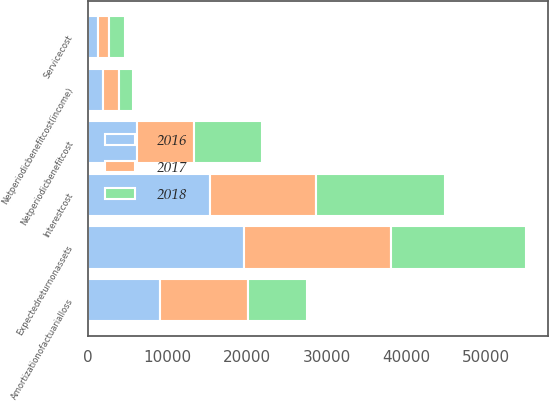Convert chart to OTSL. <chart><loc_0><loc_0><loc_500><loc_500><stacked_bar_chart><ecel><fcel>Servicecost<fcel>Interestcost<fcel>Expectedreturnonassets<fcel>Amortizationofactuarialloss<fcel>Netperiodicbenefitcost<fcel>Netperiodicbenefitcost(income)<nl><fcel>2017<fcel>1300<fcel>13358<fcel>18475<fcel>10995<fcel>7178<fcel>2092<nl><fcel>2016<fcel>1290<fcel>15303<fcel>19534<fcel>9082<fcel>6141<fcel>1870<nl><fcel>2018<fcel>2100<fcel>16106<fcel>17013<fcel>7361<fcel>8554<fcel>1707<nl></chart> 